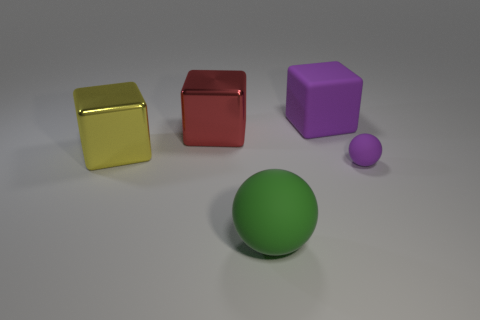What do you think is the purpose of showing these objects together? This image seems to serve as a study in contrast and comparison. It juxtaposes objects of different colors, sizes, and surface finishes to allow viewers to observe and evaluate their characteristics. It may also be used for educational purposes, like teaching about geometry, color theory, or lighting effects in photography and rendering. 